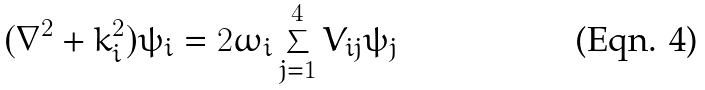<formula> <loc_0><loc_0><loc_500><loc_500>( \nabla ^ { 2 } + k _ { i } ^ { 2 } ) \psi _ { i } = 2 \omega _ { i } \sum _ { j = 1 } ^ { 4 } V _ { i j } \psi _ { j }</formula> 